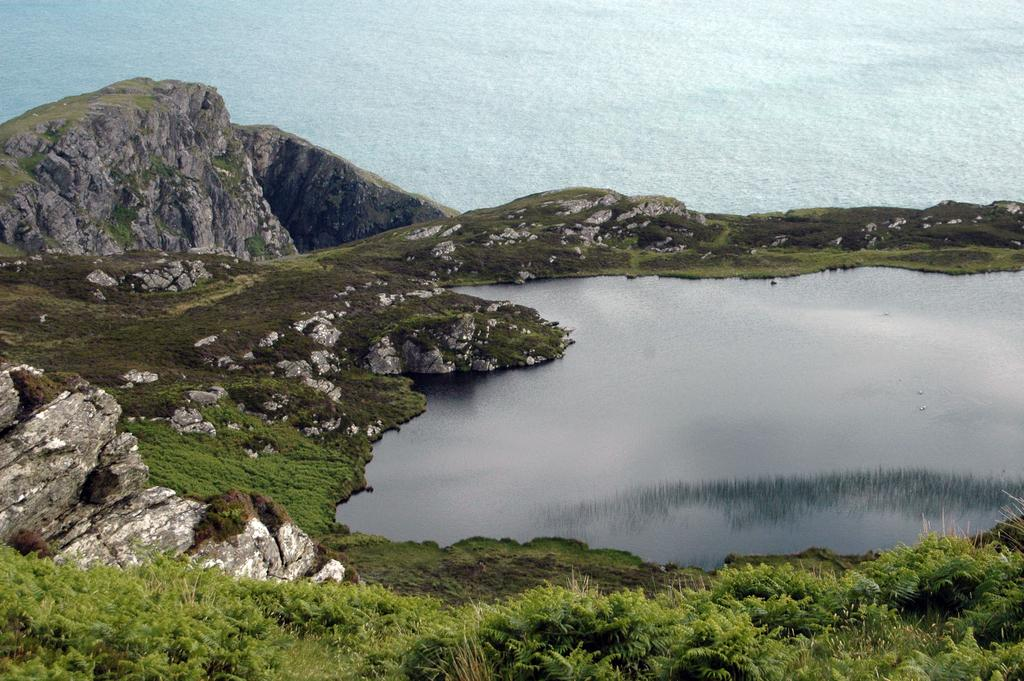What type of vegetation can be seen in the image? There is grass and plants visible in the image. What natural element is present in the image? There is water visible in the image. What type of materials can be seen in the image? There are stones and rocks visible in the image. Can you determine the time of day the image was taken? The image may have been taken during the day, but it cannot be definitively determined from the image alone. Can you determine the location of the image? The image may have been taken near the ocean, but it cannot be definitively determined from the image alone. What type of nerve is visible in the image? There is no nerve visible in the image; it features grass, plants, water, stones, and rocks. Can you see an owl in the image? There is no owl present in the image. 